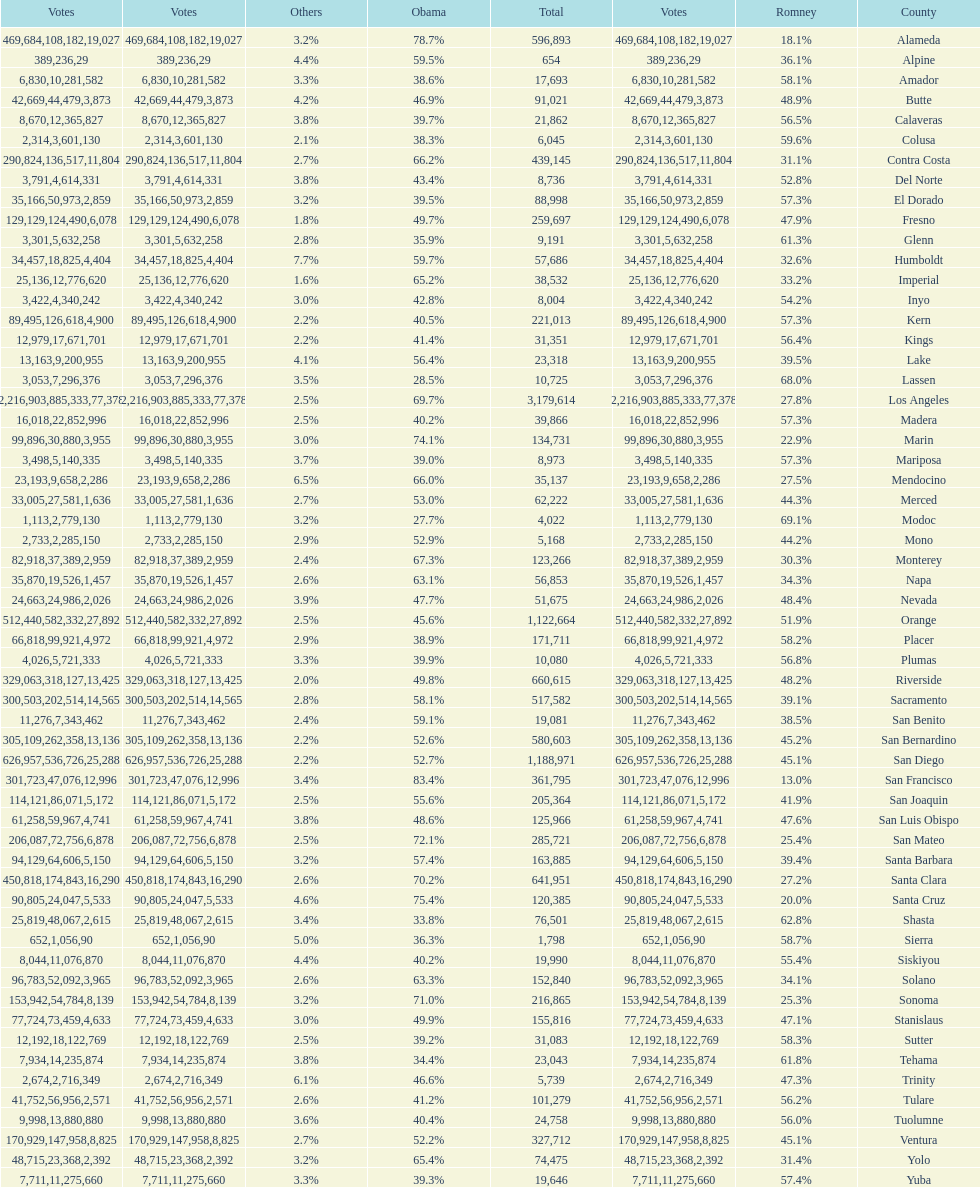What is the total number of votes for amador? 17693. 